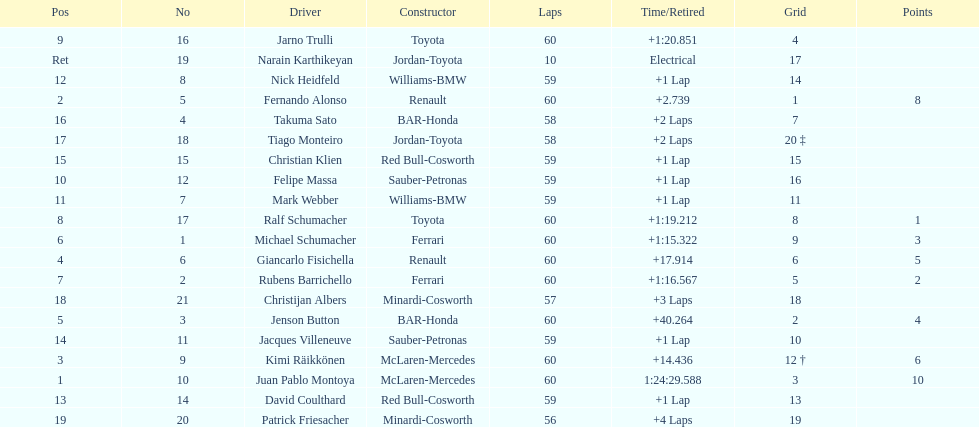How many drivers received points from the race? 8. 